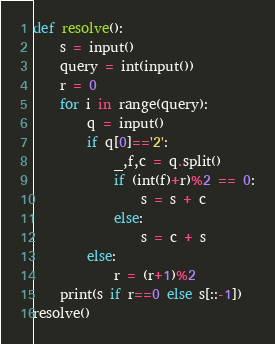Convert code to text. <code><loc_0><loc_0><loc_500><loc_500><_Python_>def resolve():
    s = input()
    query = int(input())
    r = 0
    for i in range(query):
        q = input()
        if q[0]=='2':
            _,f,c = q.split()
            if (int(f)+r)%2 == 0:
                s = s + c
            else:
                s = c + s
        else:
            r = (r+1)%2
    print(s if r==0 else s[::-1])
resolve()</code> 